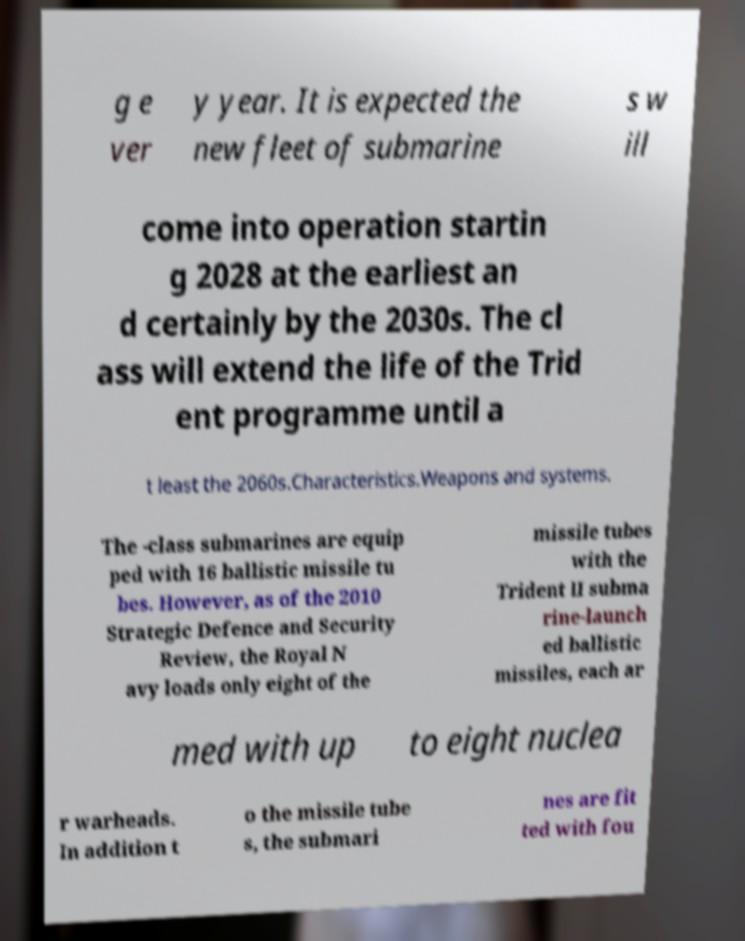Can you read and provide the text displayed in the image?This photo seems to have some interesting text. Can you extract and type it out for me? g e ver y year. It is expected the new fleet of submarine s w ill come into operation startin g 2028 at the earliest an d certainly by the 2030s. The cl ass will extend the life of the Trid ent programme until a t least the 2060s.Characteristics.Weapons and systems. The -class submarines are equip ped with 16 ballistic missile tu bes. However, as of the 2010 Strategic Defence and Security Review, the Royal N avy loads only eight of the missile tubes with the Trident II subma rine-launch ed ballistic missiles, each ar med with up to eight nuclea r warheads. In addition t o the missile tube s, the submari nes are fit ted with fou 